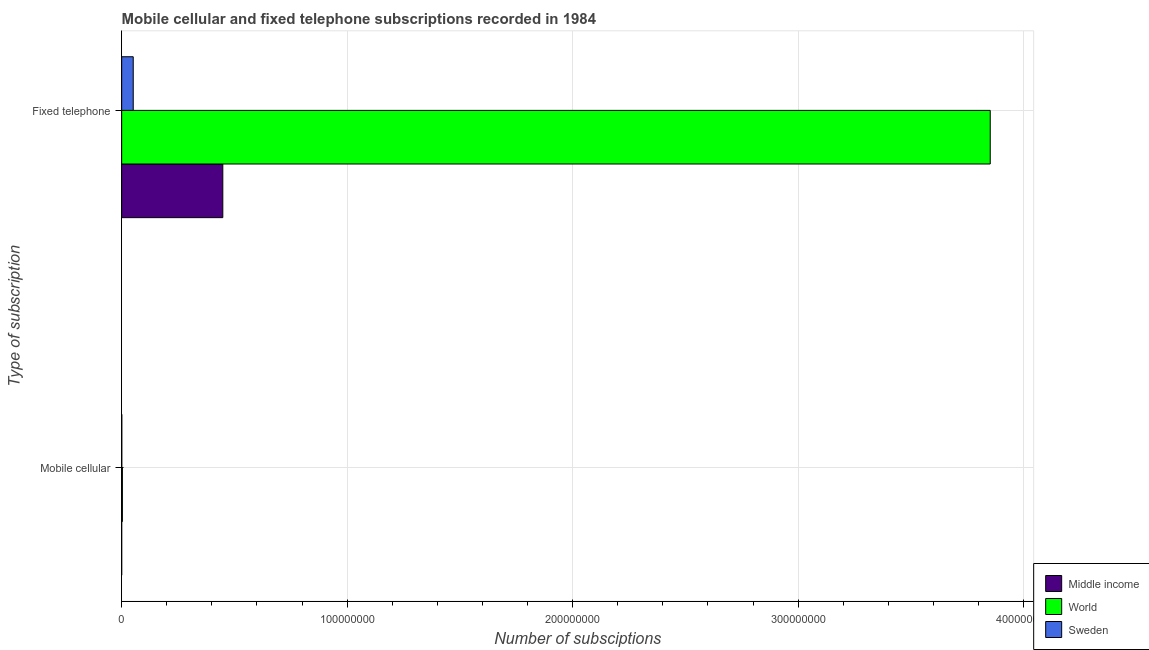How many groups of bars are there?
Provide a short and direct response. 2. Are the number of bars per tick equal to the number of legend labels?
Offer a terse response. Yes. Are the number of bars on each tick of the Y-axis equal?
Provide a short and direct response. Yes. How many bars are there on the 1st tick from the top?
Ensure brevity in your answer.  3. What is the label of the 1st group of bars from the top?
Your answer should be very brief. Fixed telephone. What is the number of mobile cellular subscriptions in World?
Ensure brevity in your answer.  3.19e+05. Across all countries, what is the maximum number of fixed telephone subscriptions?
Give a very brief answer. 3.85e+08. Across all countries, what is the minimum number of mobile cellular subscriptions?
Give a very brief answer. 1750. In which country was the number of fixed telephone subscriptions maximum?
Offer a very short reply. World. What is the total number of mobile cellular subscriptions in the graph?
Offer a very short reply. 3.79e+05. What is the difference between the number of mobile cellular subscriptions in Middle income and that in World?
Your answer should be compact. -3.18e+05. What is the difference between the number of mobile cellular subscriptions in Sweden and the number of fixed telephone subscriptions in World?
Offer a terse response. -3.85e+08. What is the average number of fixed telephone subscriptions per country?
Provide a short and direct response. 1.45e+08. What is the difference between the number of fixed telephone subscriptions and number of mobile cellular subscriptions in World?
Offer a terse response. 3.85e+08. In how many countries, is the number of fixed telephone subscriptions greater than 80000000 ?
Ensure brevity in your answer.  1. What is the ratio of the number of fixed telephone subscriptions in World to that in Middle income?
Give a very brief answer. 8.59. Is the number of fixed telephone subscriptions in Middle income less than that in World?
Provide a short and direct response. Yes. What does the 1st bar from the bottom in Fixed telephone represents?
Offer a terse response. Middle income. Does the graph contain grids?
Provide a succinct answer. Yes. What is the title of the graph?
Provide a short and direct response. Mobile cellular and fixed telephone subscriptions recorded in 1984. Does "Isle of Man" appear as one of the legend labels in the graph?
Make the answer very short. No. What is the label or title of the X-axis?
Ensure brevity in your answer.  Number of subsciptions. What is the label or title of the Y-axis?
Ensure brevity in your answer.  Type of subscription. What is the Number of subsciptions in Middle income in Mobile cellular?
Offer a very short reply. 1750. What is the Number of subsciptions of World in Mobile cellular?
Keep it short and to the point. 3.19e+05. What is the Number of subsciptions in Sweden in Mobile cellular?
Your answer should be compact. 5.79e+04. What is the Number of subsciptions in Middle income in Fixed telephone?
Make the answer very short. 4.49e+07. What is the Number of subsciptions in World in Fixed telephone?
Your response must be concise. 3.85e+08. What is the Number of subsciptions in Sweden in Fixed telephone?
Your answer should be compact. 5.13e+06. Across all Type of subscription, what is the maximum Number of subsciptions of Middle income?
Your answer should be very brief. 4.49e+07. Across all Type of subscription, what is the maximum Number of subsciptions in World?
Your answer should be very brief. 3.85e+08. Across all Type of subscription, what is the maximum Number of subsciptions in Sweden?
Your answer should be very brief. 5.13e+06. Across all Type of subscription, what is the minimum Number of subsciptions of Middle income?
Ensure brevity in your answer.  1750. Across all Type of subscription, what is the minimum Number of subsciptions of World?
Your answer should be compact. 3.19e+05. Across all Type of subscription, what is the minimum Number of subsciptions in Sweden?
Your answer should be compact. 5.79e+04. What is the total Number of subsciptions in Middle income in the graph?
Provide a succinct answer. 4.49e+07. What is the total Number of subsciptions in World in the graph?
Your response must be concise. 3.85e+08. What is the total Number of subsciptions of Sweden in the graph?
Give a very brief answer. 5.19e+06. What is the difference between the Number of subsciptions of Middle income in Mobile cellular and that in Fixed telephone?
Provide a short and direct response. -4.49e+07. What is the difference between the Number of subsciptions in World in Mobile cellular and that in Fixed telephone?
Provide a short and direct response. -3.85e+08. What is the difference between the Number of subsciptions in Sweden in Mobile cellular and that in Fixed telephone?
Offer a very short reply. -5.07e+06. What is the difference between the Number of subsciptions in Middle income in Mobile cellular and the Number of subsciptions in World in Fixed telephone?
Offer a very short reply. -3.85e+08. What is the difference between the Number of subsciptions of Middle income in Mobile cellular and the Number of subsciptions of Sweden in Fixed telephone?
Provide a short and direct response. -5.13e+06. What is the difference between the Number of subsciptions of World in Mobile cellular and the Number of subsciptions of Sweden in Fixed telephone?
Your answer should be very brief. -4.81e+06. What is the average Number of subsciptions of Middle income per Type of subscription?
Ensure brevity in your answer.  2.24e+07. What is the average Number of subsciptions in World per Type of subscription?
Provide a short and direct response. 1.93e+08. What is the average Number of subsciptions of Sweden per Type of subscription?
Offer a very short reply. 2.59e+06. What is the difference between the Number of subsciptions of Middle income and Number of subsciptions of World in Mobile cellular?
Offer a terse response. -3.18e+05. What is the difference between the Number of subsciptions of Middle income and Number of subsciptions of Sweden in Mobile cellular?
Provide a short and direct response. -5.62e+04. What is the difference between the Number of subsciptions of World and Number of subsciptions of Sweden in Mobile cellular?
Your response must be concise. 2.61e+05. What is the difference between the Number of subsciptions of Middle income and Number of subsciptions of World in Fixed telephone?
Your response must be concise. -3.40e+08. What is the difference between the Number of subsciptions of Middle income and Number of subsciptions of Sweden in Fixed telephone?
Offer a terse response. 3.97e+07. What is the difference between the Number of subsciptions of World and Number of subsciptions of Sweden in Fixed telephone?
Provide a succinct answer. 3.80e+08. What is the ratio of the Number of subsciptions of World in Mobile cellular to that in Fixed telephone?
Your answer should be compact. 0. What is the ratio of the Number of subsciptions in Sweden in Mobile cellular to that in Fixed telephone?
Give a very brief answer. 0.01. What is the difference between the highest and the second highest Number of subsciptions in Middle income?
Offer a very short reply. 4.49e+07. What is the difference between the highest and the second highest Number of subsciptions in World?
Your answer should be very brief. 3.85e+08. What is the difference between the highest and the second highest Number of subsciptions of Sweden?
Offer a terse response. 5.07e+06. What is the difference between the highest and the lowest Number of subsciptions of Middle income?
Your answer should be compact. 4.49e+07. What is the difference between the highest and the lowest Number of subsciptions of World?
Provide a short and direct response. 3.85e+08. What is the difference between the highest and the lowest Number of subsciptions of Sweden?
Your response must be concise. 5.07e+06. 